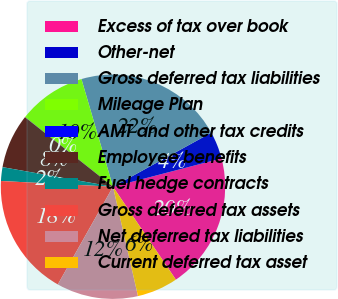Convert chart to OTSL. <chart><loc_0><loc_0><loc_500><loc_500><pie_chart><fcel>Excess of tax over book<fcel>Other-net<fcel>Gross deferred tax liabilities<fcel>Mileage Plan<fcel>AMT and other tax credits<fcel>Employee benefits<fcel>Fuel hedge contracts<fcel>Gross deferred tax assets<fcel>Net deferred tax liabilities<fcel>Current deferred tax asset<nl><fcel>19.59%<fcel>3.94%<fcel>21.54%<fcel>9.8%<fcel>0.02%<fcel>7.85%<fcel>1.98%<fcel>17.63%<fcel>11.76%<fcel>5.89%<nl></chart> 